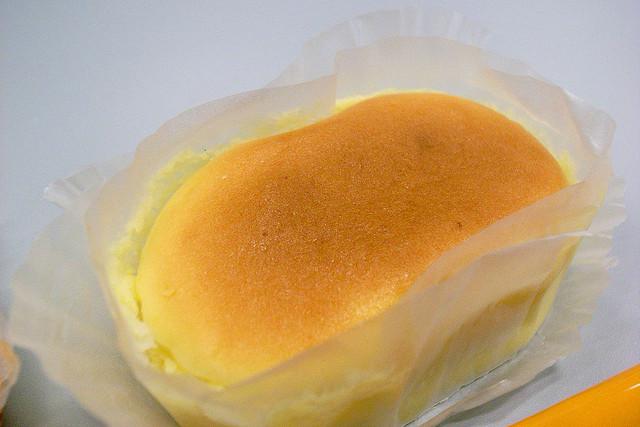What is the food wrapped in?
Keep it brief. Paper. Was this made in a restaurant or at home?
Answer briefly. Restaurant. Is this an edible item?
Concise answer only. Yes. 